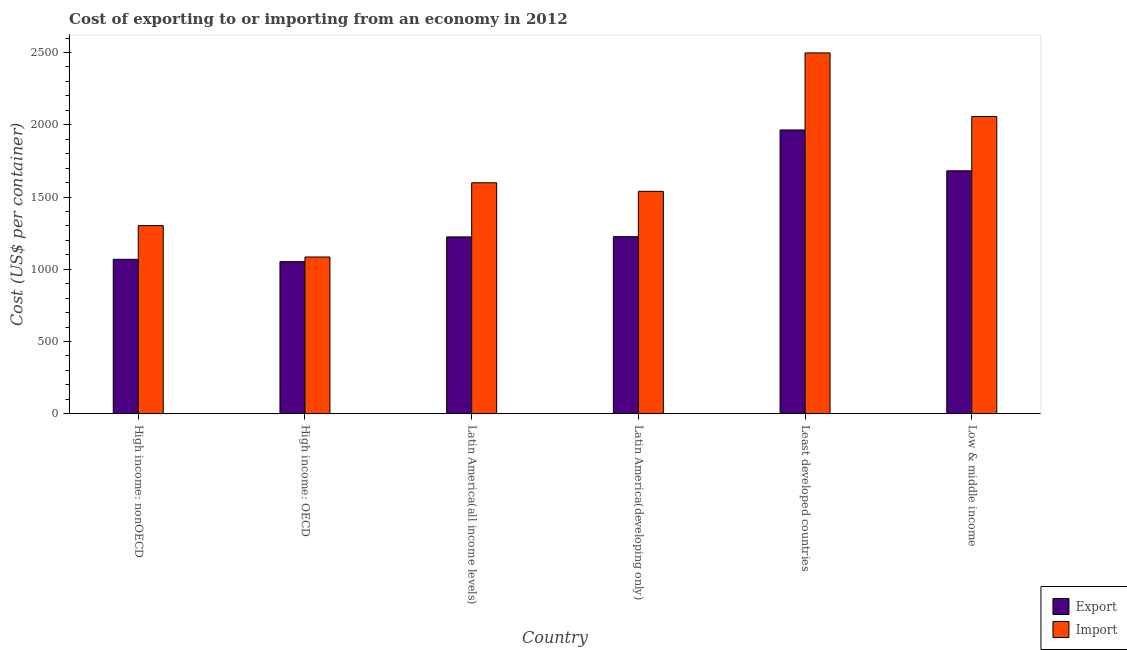How many different coloured bars are there?
Keep it short and to the point. 2. How many groups of bars are there?
Provide a short and direct response. 6. Are the number of bars on each tick of the X-axis equal?
Provide a succinct answer. Yes. How many bars are there on the 2nd tick from the right?
Provide a short and direct response. 2. What is the label of the 2nd group of bars from the left?
Make the answer very short. High income: OECD. What is the import cost in High income: nonOECD?
Offer a very short reply. 1302.32. Across all countries, what is the maximum export cost?
Your answer should be compact. 1964.04. Across all countries, what is the minimum import cost?
Make the answer very short. 1084.94. In which country was the import cost maximum?
Offer a very short reply. Least developed countries. In which country was the export cost minimum?
Provide a succinct answer. High income: OECD. What is the total export cost in the graph?
Provide a short and direct response. 8216.24. What is the difference between the import cost in Latin America(all income levels) and that in Low & middle income?
Keep it short and to the point. -458.49. What is the difference between the import cost in High income: nonOECD and the export cost in Low & middle income?
Provide a short and direct response. -379.24. What is the average export cost per country?
Provide a short and direct response. 1369.37. What is the difference between the export cost and import cost in Least developed countries?
Make the answer very short. -533.37. In how many countries, is the import cost greater than 2200 US$?
Keep it short and to the point. 1. What is the ratio of the export cost in High income: nonOECD to that in Latin America(developing only)?
Give a very brief answer. 0.87. What is the difference between the highest and the second highest import cost?
Make the answer very short. 440.29. What is the difference between the highest and the lowest import cost?
Your answer should be compact. 1412.48. Is the sum of the export cost in Latin America(all income levels) and Least developed countries greater than the maximum import cost across all countries?
Your answer should be very brief. Yes. What does the 1st bar from the left in High income: OECD represents?
Provide a short and direct response. Export. What does the 2nd bar from the right in Low & middle income represents?
Your response must be concise. Export. How many bars are there?
Ensure brevity in your answer.  12. Are all the bars in the graph horizontal?
Give a very brief answer. No. Does the graph contain any zero values?
Offer a terse response. No. Where does the legend appear in the graph?
Provide a succinct answer. Bottom right. How are the legend labels stacked?
Keep it short and to the point. Vertical. What is the title of the graph?
Offer a terse response. Cost of exporting to or importing from an economy in 2012. What is the label or title of the X-axis?
Ensure brevity in your answer.  Country. What is the label or title of the Y-axis?
Make the answer very short. Cost (US$ per container). What is the Cost (US$ per container) of Export in High income: nonOECD?
Your answer should be compact. 1068.64. What is the Cost (US$ per container) of Import in High income: nonOECD?
Keep it short and to the point. 1302.32. What is the Cost (US$ per container) of Export in High income: OECD?
Make the answer very short. 1052.53. What is the Cost (US$ per container) of Import in High income: OECD?
Provide a short and direct response. 1084.94. What is the Cost (US$ per container) of Export in Latin America(all income levels)?
Provide a short and direct response. 1223.85. What is the Cost (US$ per container) of Import in Latin America(all income levels)?
Your answer should be compact. 1598.64. What is the Cost (US$ per container) of Export in Latin America(developing only)?
Make the answer very short. 1225.61. What is the Cost (US$ per container) of Import in Latin America(developing only)?
Your answer should be compact. 1539.22. What is the Cost (US$ per container) in Export in Least developed countries?
Keep it short and to the point. 1964.04. What is the Cost (US$ per container) of Import in Least developed countries?
Your answer should be very brief. 2497.41. What is the Cost (US$ per container) of Export in Low & middle income?
Ensure brevity in your answer.  1681.57. What is the Cost (US$ per container) in Import in Low & middle income?
Offer a very short reply. 2057.12. Across all countries, what is the maximum Cost (US$ per container) in Export?
Keep it short and to the point. 1964.04. Across all countries, what is the maximum Cost (US$ per container) of Import?
Your answer should be compact. 2497.41. Across all countries, what is the minimum Cost (US$ per container) in Export?
Provide a short and direct response. 1052.53. Across all countries, what is the minimum Cost (US$ per container) in Import?
Offer a terse response. 1084.94. What is the total Cost (US$ per container) of Export in the graph?
Keep it short and to the point. 8216.24. What is the total Cost (US$ per container) in Import in the graph?
Your response must be concise. 1.01e+04. What is the difference between the Cost (US$ per container) in Export in High income: nonOECD and that in High income: OECD?
Your answer should be very brief. 16.11. What is the difference between the Cost (US$ per container) in Import in High income: nonOECD and that in High income: OECD?
Give a very brief answer. 217.38. What is the difference between the Cost (US$ per container) in Export in High income: nonOECD and that in Latin America(all income levels)?
Provide a short and direct response. -155.21. What is the difference between the Cost (US$ per container) of Import in High income: nonOECD and that in Latin America(all income levels)?
Offer a very short reply. -296.31. What is the difference between the Cost (US$ per container) of Export in High income: nonOECD and that in Latin America(developing only)?
Your answer should be compact. -156.97. What is the difference between the Cost (US$ per container) in Import in High income: nonOECD and that in Latin America(developing only)?
Make the answer very short. -236.9. What is the difference between the Cost (US$ per container) of Export in High income: nonOECD and that in Least developed countries?
Give a very brief answer. -895.4. What is the difference between the Cost (US$ per container) of Import in High income: nonOECD and that in Least developed countries?
Your answer should be compact. -1195.09. What is the difference between the Cost (US$ per container) of Export in High income: nonOECD and that in Low & middle income?
Keep it short and to the point. -612.92. What is the difference between the Cost (US$ per container) in Import in High income: nonOECD and that in Low & middle income?
Provide a succinct answer. -754.8. What is the difference between the Cost (US$ per container) of Export in High income: OECD and that in Latin America(all income levels)?
Give a very brief answer. -171.32. What is the difference between the Cost (US$ per container) in Import in High income: OECD and that in Latin America(all income levels)?
Offer a very short reply. -513.7. What is the difference between the Cost (US$ per container) in Export in High income: OECD and that in Latin America(developing only)?
Your answer should be compact. -173.08. What is the difference between the Cost (US$ per container) in Import in High income: OECD and that in Latin America(developing only)?
Give a very brief answer. -454.28. What is the difference between the Cost (US$ per container) of Export in High income: OECD and that in Least developed countries?
Provide a short and direct response. -911.51. What is the difference between the Cost (US$ per container) in Import in High income: OECD and that in Least developed countries?
Your answer should be compact. -1412.48. What is the difference between the Cost (US$ per container) of Export in High income: OECD and that in Low & middle income?
Ensure brevity in your answer.  -629.03. What is the difference between the Cost (US$ per container) of Import in High income: OECD and that in Low & middle income?
Make the answer very short. -972.19. What is the difference between the Cost (US$ per container) in Export in Latin America(all income levels) and that in Latin America(developing only)?
Offer a terse response. -1.76. What is the difference between the Cost (US$ per container) in Import in Latin America(all income levels) and that in Latin America(developing only)?
Your answer should be very brief. 59.42. What is the difference between the Cost (US$ per container) in Export in Latin America(all income levels) and that in Least developed countries?
Ensure brevity in your answer.  -740.2. What is the difference between the Cost (US$ per container) of Import in Latin America(all income levels) and that in Least developed countries?
Offer a very short reply. -898.78. What is the difference between the Cost (US$ per container) of Export in Latin America(all income levels) and that in Low & middle income?
Provide a succinct answer. -457.72. What is the difference between the Cost (US$ per container) of Import in Latin America(all income levels) and that in Low & middle income?
Offer a terse response. -458.49. What is the difference between the Cost (US$ per container) of Export in Latin America(developing only) and that in Least developed countries?
Make the answer very short. -738.43. What is the difference between the Cost (US$ per container) in Import in Latin America(developing only) and that in Least developed countries?
Your answer should be compact. -958.2. What is the difference between the Cost (US$ per container) in Export in Latin America(developing only) and that in Low & middle income?
Offer a terse response. -455.96. What is the difference between the Cost (US$ per container) of Import in Latin America(developing only) and that in Low & middle income?
Your answer should be very brief. -517.91. What is the difference between the Cost (US$ per container) in Export in Least developed countries and that in Low & middle income?
Keep it short and to the point. 282.48. What is the difference between the Cost (US$ per container) in Import in Least developed countries and that in Low & middle income?
Keep it short and to the point. 440.29. What is the difference between the Cost (US$ per container) in Export in High income: nonOECD and the Cost (US$ per container) in Import in High income: OECD?
Keep it short and to the point. -16.29. What is the difference between the Cost (US$ per container) of Export in High income: nonOECD and the Cost (US$ per container) of Import in Latin America(all income levels)?
Give a very brief answer. -529.99. What is the difference between the Cost (US$ per container) of Export in High income: nonOECD and the Cost (US$ per container) of Import in Latin America(developing only)?
Provide a succinct answer. -470.57. What is the difference between the Cost (US$ per container) in Export in High income: nonOECD and the Cost (US$ per container) in Import in Least developed countries?
Your answer should be very brief. -1428.77. What is the difference between the Cost (US$ per container) of Export in High income: nonOECD and the Cost (US$ per container) of Import in Low & middle income?
Give a very brief answer. -988.48. What is the difference between the Cost (US$ per container) of Export in High income: OECD and the Cost (US$ per container) of Import in Latin America(all income levels)?
Provide a succinct answer. -546.11. What is the difference between the Cost (US$ per container) in Export in High income: OECD and the Cost (US$ per container) in Import in Latin America(developing only)?
Keep it short and to the point. -486.69. What is the difference between the Cost (US$ per container) in Export in High income: OECD and the Cost (US$ per container) in Import in Least developed countries?
Offer a terse response. -1444.88. What is the difference between the Cost (US$ per container) in Export in High income: OECD and the Cost (US$ per container) in Import in Low & middle income?
Give a very brief answer. -1004.59. What is the difference between the Cost (US$ per container) of Export in Latin America(all income levels) and the Cost (US$ per container) of Import in Latin America(developing only)?
Provide a succinct answer. -315.37. What is the difference between the Cost (US$ per container) in Export in Latin America(all income levels) and the Cost (US$ per container) in Import in Least developed countries?
Make the answer very short. -1273.56. What is the difference between the Cost (US$ per container) of Export in Latin America(all income levels) and the Cost (US$ per container) of Import in Low & middle income?
Provide a succinct answer. -833.28. What is the difference between the Cost (US$ per container) of Export in Latin America(developing only) and the Cost (US$ per container) of Import in Least developed countries?
Offer a very short reply. -1271.8. What is the difference between the Cost (US$ per container) of Export in Latin America(developing only) and the Cost (US$ per container) of Import in Low & middle income?
Provide a succinct answer. -831.52. What is the difference between the Cost (US$ per container) in Export in Least developed countries and the Cost (US$ per container) in Import in Low & middle income?
Provide a short and direct response. -93.08. What is the average Cost (US$ per container) of Export per country?
Offer a very short reply. 1369.37. What is the average Cost (US$ per container) of Import per country?
Ensure brevity in your answer.  1679.94. What is the difference between the Cost (US$ per container) in Export and Cost (US$ per container) in Import in High income: nonOECD?
Your answer should be very brief. -233.68. What is the difference between the Cost (US$ per container) in Export and Cost (US$ per container) in Import in High income: OECD?
Make the answer very short. -32.41. What is the difference between the Cost (US$ per container) of Export and Cost (US$ per container) of Import in Latin America(all income levels)?
Offer a very short reply. -374.79. What is the difference between the Cost (US$ per container) in Export and Cost (US$ per container) in Import in Latin America(developing only)?
Your response must be concise. -313.61. What is the difference between the Cost (US$ per container) of Export and Cost (US$ per container) of Import in Least developed countries?
Keep it short and to the point. -533.37. What is the difference between the Cost (US$ per container) of Export and Cost (US$ per container) of Import in Low & middle income?
Keep it short and to the point. -375.56. What is the ratio of the Cost (US$ per container) of Export in High income: nonOECD to that in High income: OECD?
Provide a short and direct response. 1.02. What is the ratio of the Cost (US$ per container) in Import in High income: nonOECD to that in High income: OECD?
Make the answer very short. 1.2. What is the ratio of the Cost (US$ per container) in Export in High income: nonOECD to that in Latin America(all income levels)?
Provide a succinct answer. 0.87. What is the ratio of the Cost (US$ per container) of Import in High income: nonOECD to that in Latin America(all income levels)?
Provide a short and direct response. 0.81. What is the ratio of the Cost (US$ per container) of Export in High income: nonOECD to that in Latin America(developing only)?
Keep it short and to the point. 0.87. What is the ratio of the Cost (US$ per container) of Import in High income: nonOECD to that in Latin America(developing only)?
Keep it short and to the point. 0.85. What is the ratio of the Cost (US$ per container) in Export in High income: nonOECD to that in Least developed countries?
Keep it short and to the point. 0.54. What is the ratio of the Cost (US$ per container) in Import in High income: nonOECD to that in Least developed countries?
Offer a terse response. 0.52. What is the ratio of the Cost (US$ per container) in Export in High income: nonOECD to that in Low & middle income?
Offer a very short reply. 0.64. What is the ratio of the Cost (US$ per container) in Import in High income: nonOECD to that in Low & middle income?
Your answer should be compact. 0.63. What is the ratio of the Cost (US$ per container) of Export in High income: OECD to that in Latin America(all income levels)?
Give a very brief answer. 0.86. What is the ratio of the Cost (US$ per container) in Import in High income: OECD to that in Latin America(all income levels)?
Offer a very short reply. 0.68. What is the ratio of the Cost (US$ per container) in Export in High income: OECD to that in Latin America(developing only)?
Your answer should be very brief. 0.86. What is the ratio of the Cost (US$ per container) in Import in High income: OECD to that in Latin America(developing only)?
Keep it short and to the point. 0.7. What is the ratio of the Cost (US$ per container) in Export in High income: OECD to that in Least developed countries?
Your response must be concise. 0.54. What is the ratio of the Cost (US$ per container) of Import in High income: OECD to that in Least developed countries?
Give a very brief answer. 0.43. What is the ratio of the Cost (US$ per container) of Export in High income: OECD to that in Low & middle income?
Offer a very short reply. 0.63. What is the ratio of the Cost (US$ per container) of Import in High income: OECD to that in Low & middle income?
Keep it short and to the point. 0.53. What is the ratio of the Cost (US$ per container) of Export in Latin America(all income levels) to that in Latin America(developing only)?
Make the answer very short. 1. What is the ratio of the Cost (US$ per container) of Import in Latin America(all income levels) to that in Latin America(developing only)?
Offer a very short reply. 1.04. What is the ratio of the Cost (US$ per container) of Export in Latin America(all income levels) to that in Least developed countries?
Your answer should be very brief. 0.62. What is the ratio of the Cost (US$ per container) of Import in Latin America(all income levels) to that in Least developed countries?
Your answer should be compact. 0.64. What is the ratio of the Cost (US$ per container) in Export in Latin America(all income levels) to that in Low & middle income?
Keep it short and to the point. 0.73. What is the ratio of the Cost (US$ per container) in Import in Latin America(all income levels) to that in Low & middle income?
Keep it short and to the point. 0.78. What is the ratio of the Cost (US$ per container) in Export in Latin America(developing only) to that in Least developed countries?
Offer a very short reply. 0.62. What is the ratio of the Cost (US$ per container) in Import in Latin America(developing only) to that in Least developed countries?
Keep it short and to the point. 0.62. What is the ratio of the Cost (US$ per container) of Export in Latin America(developing only) to that in Low & middle income?
Keep it short and to the point. 0.73. What is the ratio of the Cost (US$ per container) of Import in Latin America(developing only) to that in Low & middle income?
Provide a short and direct response. 0.75. What is the ratio of the Cost (US$ per container) in Export in Least developed countries to that in Low & middle income?
Give a very brief answer. 1.17. What is the ratio of the Cost (US$ per container) of Import in Least developed countries to that in Low & middle income?
Ensure brevity in your answer.  1.21. What is the difference between the highest and the second highest Cost (US$ per container) of Export?
Provide a succinct answer. 282.48. What is the difference between the highest and the second highest Cost (US$ per container) in Import?
Your response must be concise. 440.29. What is the difference between the highest and the lowest Cost (US$ per container) in Export?
Give a very brief answer. 911.51. What is the difference between the highest and the lowest Cost (US$ per container) of Import?
Provide a short and direct response. 1412.48. 